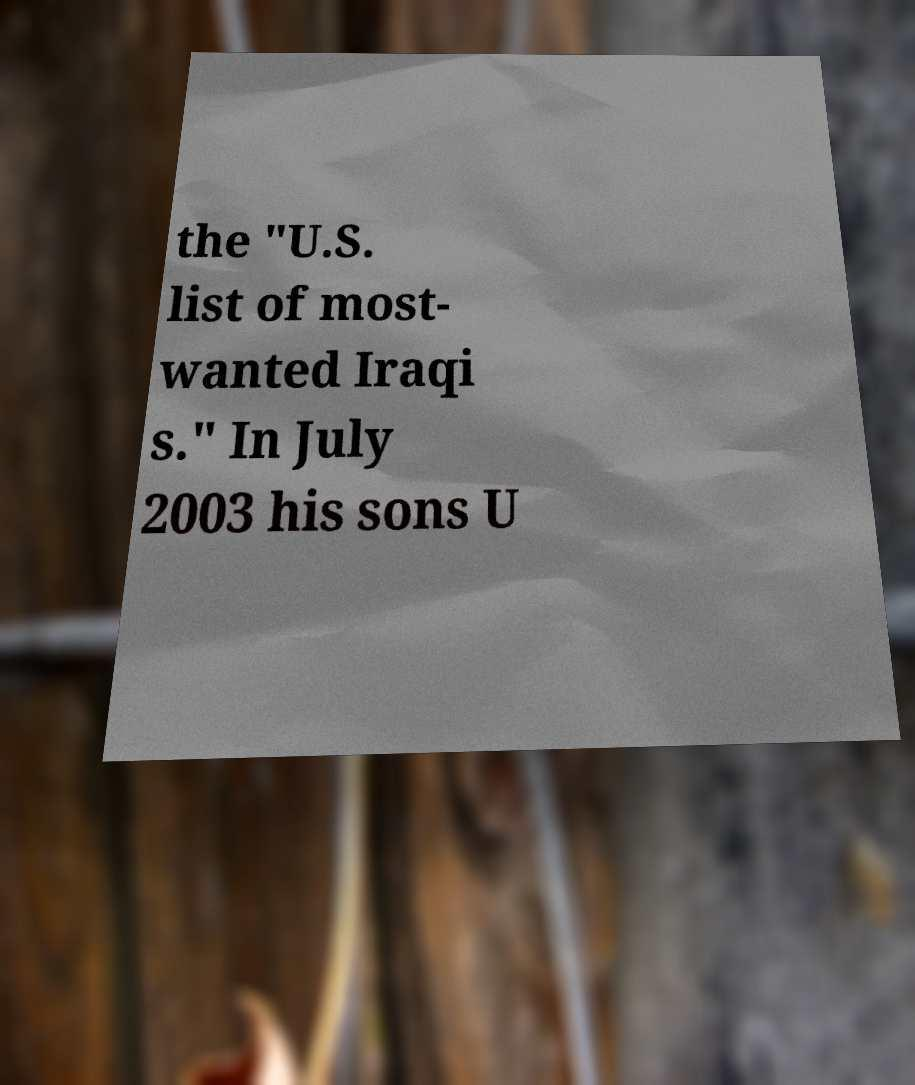There's text embedded in this image that I need extracted. Can you transcribe it verbatim? the "U.S. list of most- wanted Iraqi s." In July 2003 his sons U 